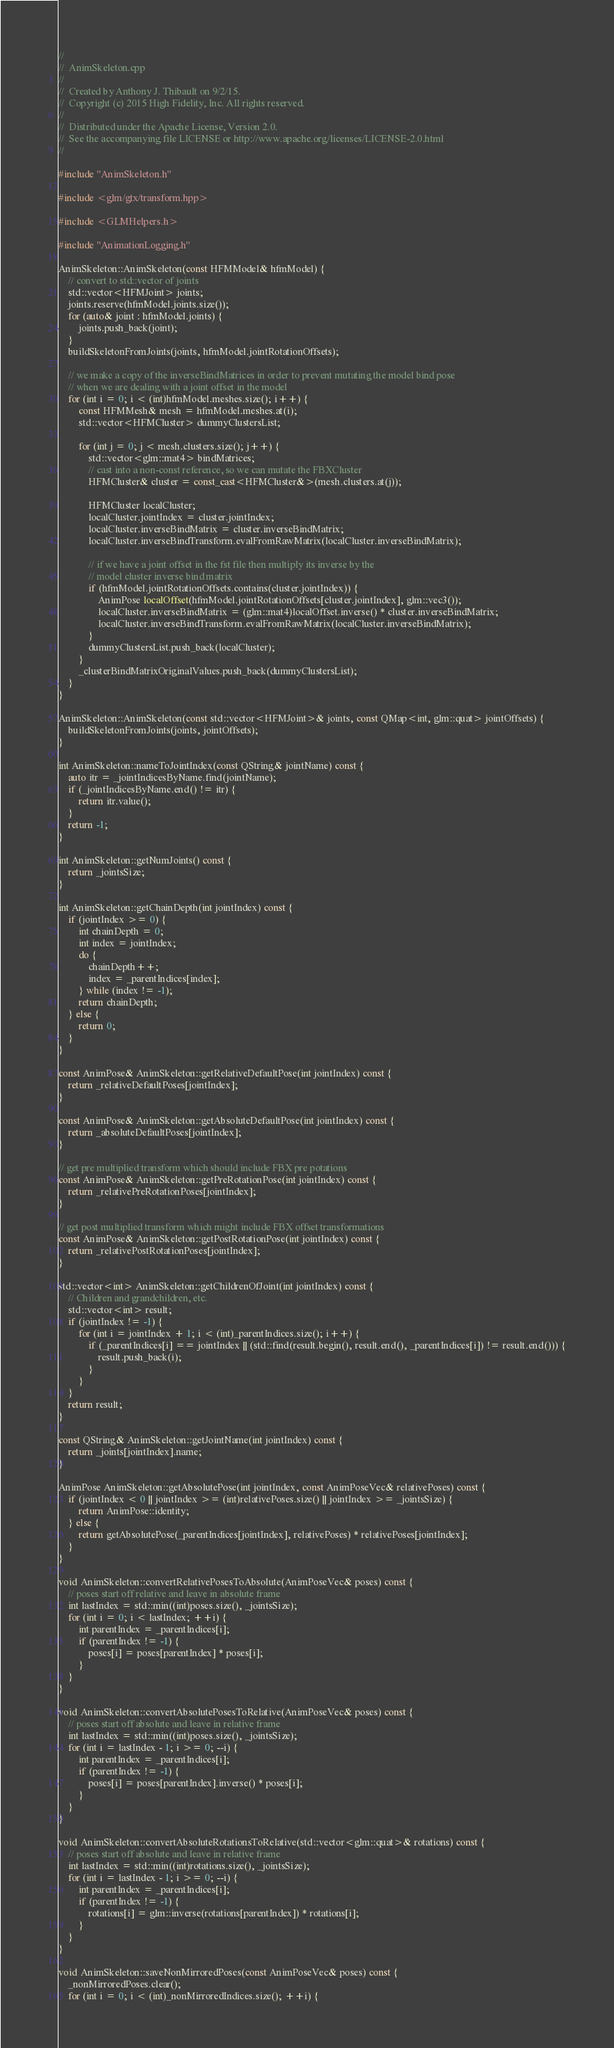<code> <loc_0><loc_0><loc_500><loc_500><_C++_>//
//  AnimSkeleton.cpp
//
//  Created by Anthony J. Thibault on 9/2/15.
//  Copyright (c) 2015 High Fidelity, Inc. All rights reserved.
//
//  Distributed under the Apache License, Version 2.0.
//  See the accompanying file LICENSE or http://www.apache.org/licenses/LICENSE-2.0.html
//

#include "AnimSkeleton.h"

#include <glm/gtx/transform.hpp>

#include <GLMHelpers.h>

#include "AnimationLogging.h"

AnimSkeleton::AnimSkeleton(const HFMModel& hfmModel) {
    // convert to std::vector of joints
    std::vector<HFMJoint> joints;
    joints.reserve(hfmModel.joints.size());
    for (auto& joint : hfmModel.joints) {
        joints.push_back(joint);
    }
    buildSkeletonFromJoints(joints, hfmModel.jointRotationOffsets);

    // we make a copy of the inverseBindMatrices in order to prevent mutating the model bind pose
    // when we are dealing with a joint offset in the model
    for (int i = 0; i < (int)hfmModel.meshes.size(); i++) {
        const HFMMesh& mesh = hfmModel.meshes.at(i);
        std::vector<HFMCluster> dummyClustersList;

        for (int j = 0; j < mesh.clusters.size(); j++) {
            std::vector<glm::mat4> bindMatrices;
            // cast into a non-const reference, so we can mutate the FBXCluster
            HFMCluster& cluster = const_cast<HFMCluster&>(mesh.clusters.at(j));

            HFMCluster localCluster;
            localCluster.jointIndex = cluster.jointIndex;
            localCluster.inverseBindMatrix = cluster.inverseBindMatrix;
            localCluster.inverseBindTransform.evalFromRawMatrix(localCluster.inverseBindMatrix);

            // if we have a joint offset in the fst file then multiply its inverse by the
            // model cluster inverse bind matrix
            if (hfmModel.jointRotationOffsets.contains(cluster.jointIndex)) {
                AnimPose localOffset(hfmModel.jointRotationOffsets[cluster.jointIndex], glm::vec3());
                localCluster.inverseBindMatrix = (glm::mat4)localOffset.inverse() * cluster.inverseBindMatrix;
                localCluster.inverseBindTransform.evalFromRawMatrix(localCluster.inverseBindMatrix);
            }
            dummyClustersList.push_back(localCluster);
        }
        _clusterBindMatrixOriginalValues.push_back(dummyClustersList);
    }
}

AnimSkeleton::AnimSkeleton(const std::vector<HFMJoint>& joints, const QMap<int, glm::quat> jointOffsets) {
    buildSkeletonFromJoints(joints, jointOffsets);
}

int AnimSkeleton::nameToJointIndex(const QString& jointName) const {
    auto itr = _jointIndicesByName.find(jointName);
    if (_jointIndicesByName.end() != itr) {
        return itr.value();
    }
    return -1;
}

int AnimSkeleton::getNumJoints() const {
    return _jointsSize;
}

int AnimSkeleton::getChainDepth(int jointIndex) const {
    if (jointIndex >= 0) {
        int chainDepth = 0;
        int index = jointIndex;
        do {
            chainDepth++;
            index = _parentIndices[index];
        } while (index != -1);
        return chainDepth;
    } else {
        return 0;
    }
}

const AnimPose& AnimSkeleton::getRelativeDefaultPose(int jointIndex) const {
    return _relativeDefaultPoses[jointIndex];
}

const AnimPose& AnimSkeleton::getAbsoluteDefaultPose(int jointIndex) const {
    return _absoluteDefaultPoses[jointIndex];
}

// get pre multiplied transform which should include FBX pre potations
const AnimPose& AnimSkeleton::getPreRotationPose(int jointIndex) const {
    return _relativePreRotationPoses[jointIndex];
}

// get post multiplied transform which might include FBX offset transformations
const AnimPose& AnimSkeleton::getPostRotationPose(int jointIndex) const {
    return _relativePostRotationPoses[jointIndex];
}

std::vector<int> AnimSkeleton::getChildrenOfJoint(int jointIndex) const {
    // Children and grandchildren, etc.
    std::vector<int> result;
    if (jointIndex != -1) {
        for (int i = jointIndex + 1; i < (int)_parentIndices.size(); i++) {
            if (_parentIndices[i] == jointIndex || (std::find(result.begin(), result.end(), _parentIndices[i]) != result.end())) {
                result.push_back(i);
            }
        }
    }
    return result;
}

const QString& AnimSkeleton::getJointName(int jointIndex) const {
    return _joints[jointIndex].name;
}

AnimPose AnimSkeleton::getAbsolutePose(int jointIndex, const AnimPoseVec& relativePoses) const {
    if (jointIndex < 0 || jointIndex >= (int)relativePoses.size() || jointIndex >= _jointsSize) {
        return AnimPose::identity;
    } else {
        return getAbsolutePose(_parentIndices[jointIndex], relativePoses) * relativePoses[jointIndex];
    }
}

void AnimSkeleton::convertRelativePosesToAbsolute(AnimPoseVec& poses) const {
    // poses start off relative and leave in absolute frame
    int lastIndex = std::min((int)poses.size(), _jointsSize);
    for (int i = 0; i < lastIndex; ++i) {
        int parentIndex = _parentIndices[i];
        if (parentIndex != -1) {
            poses[i] = poses[parentIndex] * poses[i];
        }
    }
}

void AnimSkeleton::convertAbsolutePosesToRelative(AnimPoseVec& poses) const {
    // poses start off absolute and leave in relative frame
    int lastIndex = std::min((int)poses.size(), _jointsSize);
    for (int i = lastIndex - 1; i >= 0; --i) {
        int parentIndex = _parentIndices[i];
        if (parentIndex != -1) {
            poses[i] = poses[parentIndex].inverse() * poses[i];
        }
    }
}

void AnimSkeleton::convertAbsoluteRotationsToRelative(std::vector<glm::quat>& rotations) const {
    // poses start off absolute and leave in relative frame
    int lastIndex = std::min((int)rotations.size(), _jointsSize);
    for (int i = lastIndex - 1; i >= 0; --i) {
        int parentIndex = _parentIndices[i];
        if (parentIndex != -1) {
            rotations[i] = glm::inverse(rotations[parentIndex]) * rotations[i];
        }
    }
}

void AnimSkeleton::saveNonMirroredPoses(const AnimPoseVec& poses) const {
    _nonMirroredPoses.clear();
    for (int i = 0; i < (int)_nonMirroredIndices.size(); ++i) {</code> 